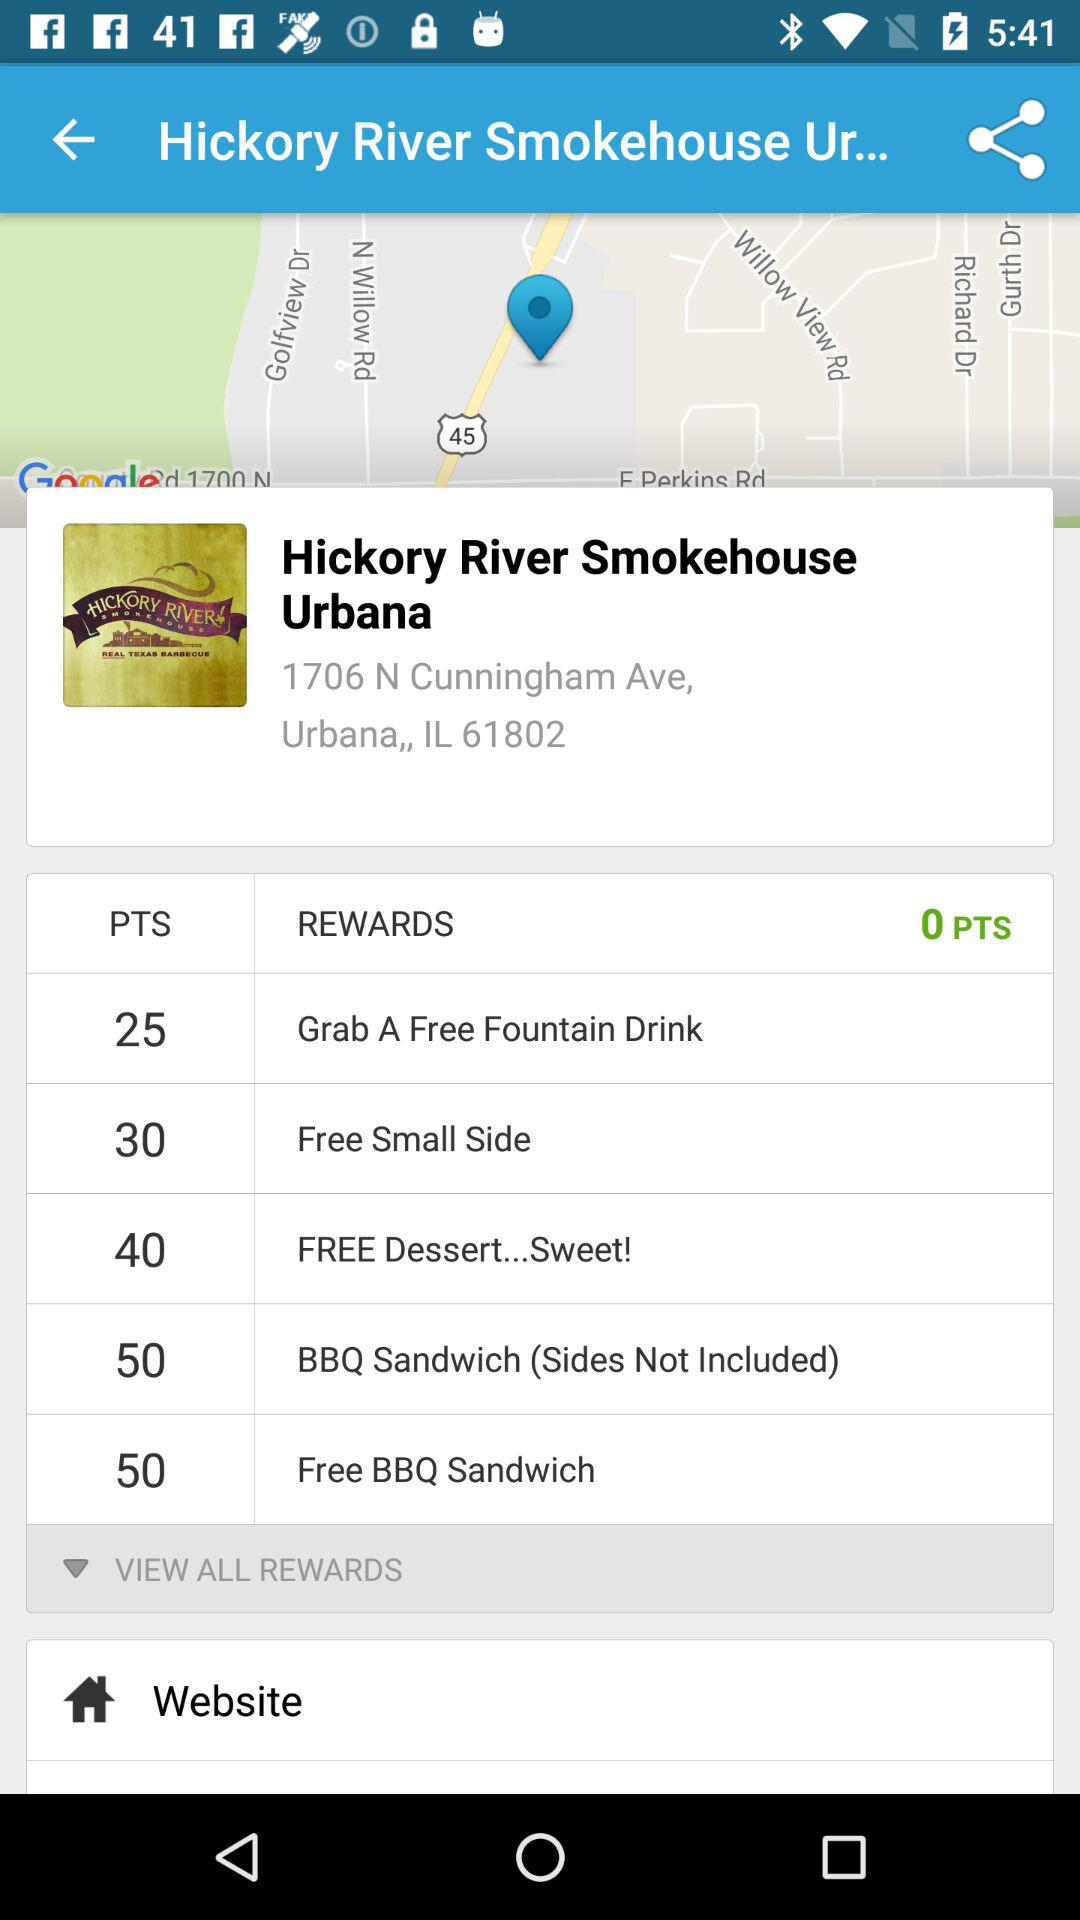How many points are given for the "Free BBQ Sandwich" reward? The number of points given for the "Free BBQ Sandwich" reward is 50. 